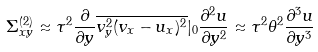<formula> <loc_0><loc_0><loc_500><loc_500>\Sigma _ { x y } ^ { ( 2 ) } \approx \tau ^ { 2 } \frac { \partial } { \partial y } \overline { v _ { y } ^ { 2 } ( v _ { x } - u _ { x } ) ^ { 2 } } | _ { 0 } \frac { \partial ^ { 2 } u } { \partial y ^ { 2 } } \approx \tau ^ { 2 } \theta ^ { 2 } \frac { \partial ^ { 3 } u } { \partial y ^ { 3 } }</formula> 